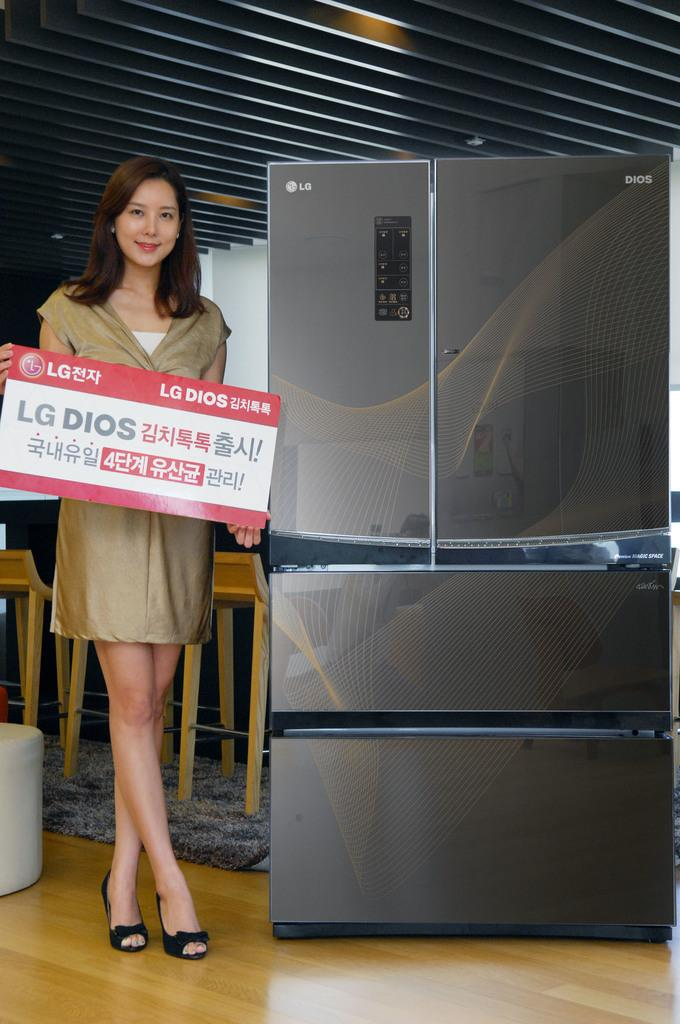<image>
Write a terse but informative summary of the picture. A woman stands by a refrigerator with a sign with LG DIOS. 